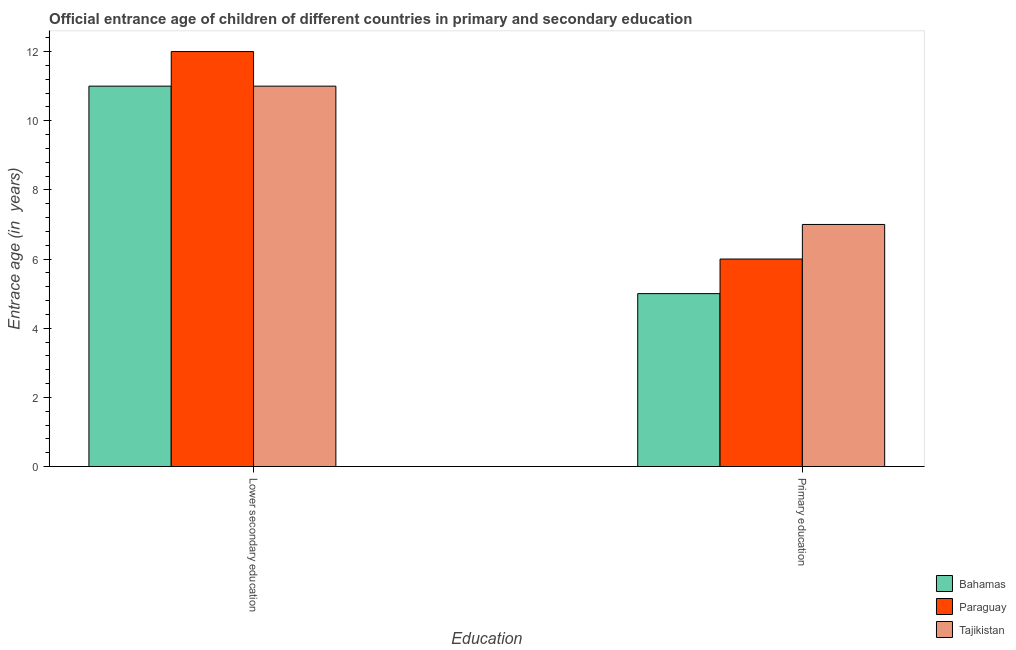Are the number of bars on each tick of the X-axis equal?
Your answer should be very brief. Yes. How many bars are there on the 2nd tick from the left?
Provide a succinct answer. 3. How many bars are there on the 2nd tick from the right?
Give a very brief answer. 3. What is the label of the 1st group of bars from the left?
Offer a very short reply. Lower secondary education. What is the entrance age of chiildren in primary education in Tajikistan?
Provide a short and direct response. 7. Across all countries, what is the maximum entrance age of chiildren in primary education?
Keep it short and to the point. 7. Across all countries, what is the minimum entrance age of children in lower secondary education?
Give a very brief answer. 11. In which country was the entrance age of children in lower secondary education maximum?
Your answer should be very brief. Paraguay. In which country was the entrance age of children in lower secondary education minimum?
Ensure brevity in your answer.  Bahamas. What is the total entrance age of children in lower secondary education in the graph?
Provide a short and direct response. 34. What is the difference between the entrance age of chiildren in primary education in Tajikistan and that in Paraguay?
Keep it short and to the point. 1. What is the difference between the entrance age of chiildren in primary education in Bahamas and the entrance age of children in lower secondary education in Paraguay?
Make the answer very short. -7. What is the ratio of the entrance age of children in lower secondary education in Tajikistan to that in Paraguay?
Make the answer very short. 0.92. Is the entrance age of children in lower secondary education in Tajikistan less than that in Bahamas?
Give a very brief answer. No. What does the 3rd bar from the left in Lower secondary education represents?
Make the answer very short. Tajikistan. What does the 3rd bar from the right in Lower secondary education represents?
Give a very brief answer. Bahamas. Are all the bars in the graph horizontal?
Your answer should be very brief. No. How many countries are there in the graph?
Your response must be concise. 3. What is the difference between two consecutive major ticks on the Y-axis?
Ensure brevity in your answer.  2. Are the values on the major ticks of Y-axis written in scientific E-notation?
Ensure brevity in your answer.  No. Where does the legend appear in the graph?
Provide a succinct answer. Bottom right. How are the legend labels stacked?
Your answer should be compact. Vertical. What is the title of the graph?
Ensure brevity in your answer.  Official entrance age of children of different countries in primary and secondary education. What is the label or title of the X-axis?
Make the answer very short. Education. What is the label or title of the Y-axis?
Give a very brief answer. Entrace age (in  years). What is the Entrace age (in  years) of Paraguay in Lower secondary education?
Your response must be concise. 12. What is the Entrace age (in  years) of Tajikistan in Lower secondary education?
Keep it short and to the point. 11. Across all Education, what is the maximum Entrace age (in  years) in Tajikistan?
Offer a very short reply. 11. What is the total Entrace age (in  years) in Paraguay in the graph?
Your response must be concise. 18. What is the difference between the Entrace age (in  years) of Paraguay in Lower secondary education and that in Primary education?
Ensure brevity in your answer.  6. What is the difference between the Entrace age (in  years) in Tajikistan in Lower secondary education and that in Primary education?
Give a very brief answer. 4. What is the difference between the Entrace age (in  years) in Bahamas in Lower secondary education and the Entrace age (in  years) in Paraguay in Primary education?
Your response must be concise. 5. What is the difference between the Entrace age (in  years) of Bahamas and Entrace age (in  years) of Paraguay in Lower secondary education?
Your answer should be compact. -1. What is the difference between the Entrace age (in  years) of Bahamas and Entrace age (in  years) of Tajikistan in Primary education?
Your response must be concise. -2. What is the difference between the Entrace age (in  years) in Paraguay and Entrace age (in  years) in Tajikistan in Primary education?
Provide a short and direct response. -1. What is the ratio of the Entrace age (in  years) of Bahamas in Lower secondary education to that in Primary education?
Give a very brief answer. 2.2. What is the ratio of the Entrace age (in  years) of Tajikistan in Lower secondary education to that in Primary education?
Provide a short and direct response. 1.57. What is the difference between the highest and the second highest Entrace age (in  years) of Tajikistan?
Provide a short and direct response. 4. What is the difference between the highest and the lowest Entrace age (in  years) in Bahamas?
Your answer should be compact. 6. What is the difference between the highest and the lowest Entrace age (in  years) in Tajikistan?
Keep it short and to the point. 4. 